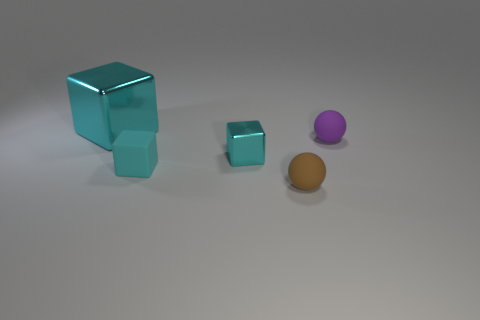Subtract all cyan blocks. How many were subtracted if there are1cyan blocks left? 2 Subtract all cyan metallic blocks. How many blocks are left? 1 Add 5 brown balls. How many objects exist? 10 Subtract all spheres. How many objects are left? 3 Subtract 0 red cylinders. How many objects are left? 5 Subtract all large green shiny cylinders. Subtract all big metal objects. How many objects are left? 4 Add 1 tiny matte objects. How many tiny matte objects are left? 4 Add 4 purple balls. How many purple balls exist? 5 